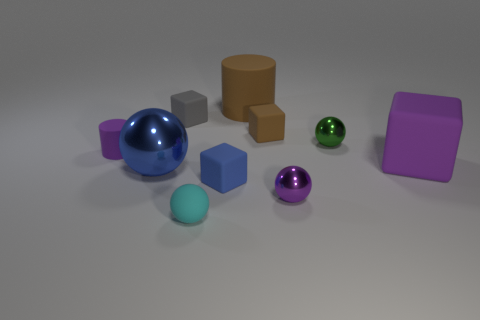Subtract 1 blocks. How many blocks are left? 3 Subtract all cylinders. How many objects are left? 8 Subtract all purple blocks. Subtract all balls. How many objects are left? 5 Add 3 matte things. How many matte things are left? 10 Add 4 purple cubes. How many purple cubes exist? 5 Subtract 1 blue spheres. How many objects are left? 9 